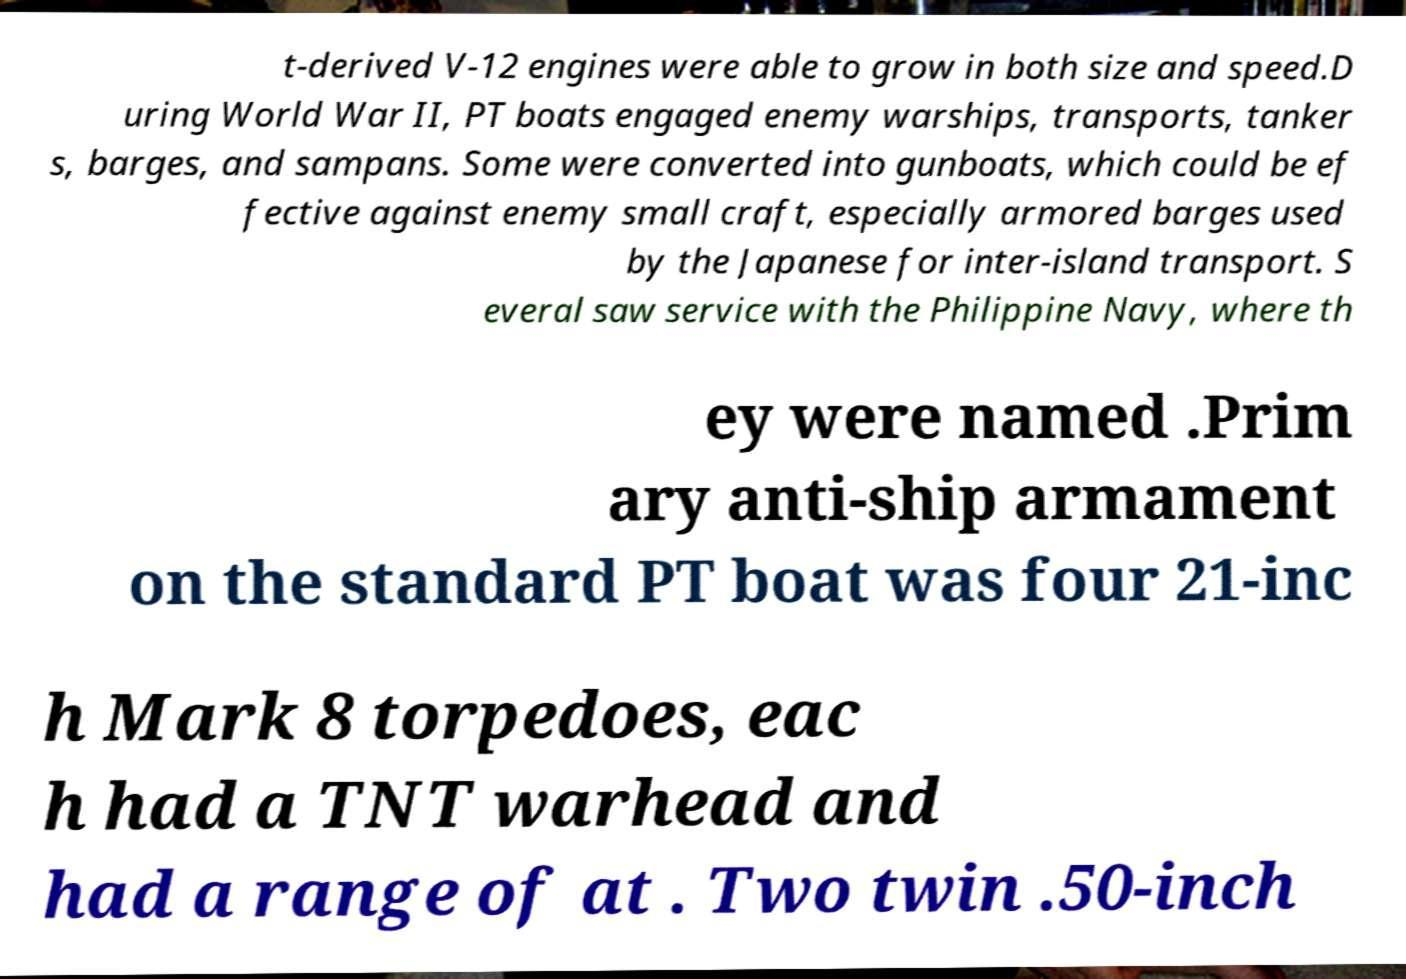Please read and relay the text visible in this image. What does it say? t-derived V-12 engines were able to grow in both size and speed.D uring World War II, PT boats engaged enemy warships, transports, tanker s, barges, and sampans. Some were converted into gunboats, which could be ef fective against enemy small craft, especially armored barges used by the Japanese for inter-island transport. S everal saw service with the Philippine Navy, where th ey were named .Prim ary anti-ship armament on the standard PT boat was four 21-inc h Mark 8 torpedoes, eac h had a TNT warhead and had a range of at . Two twin .50-inch 